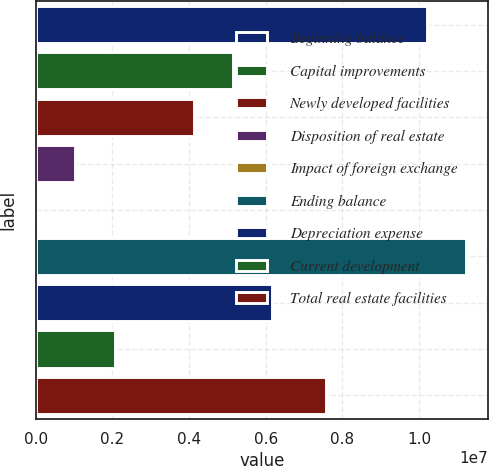<chart> <loc_0><loc_0><loc_500><loc_500><bar_chart><fcel>Beginning balance<fcel>Capital improvements<fcel>Newly developed facilities<fcel>Disposition of real estate<fcel>Impact of foreign exchange<fcel>Ending balance<fcel>Depreciation expense<fcel>Current development<fcel>Total real estate facilities<nl><fcel>1.0207e+07<fcel>5.14749e+06<fcel>4.1184e+06<fcel>1.03112e+06<fcel>2022<fcel>1.12361e+07<fcel>6.17658e+06<fcel>2.06021e+06<fcel>7.56203e+06<nl></chart> 